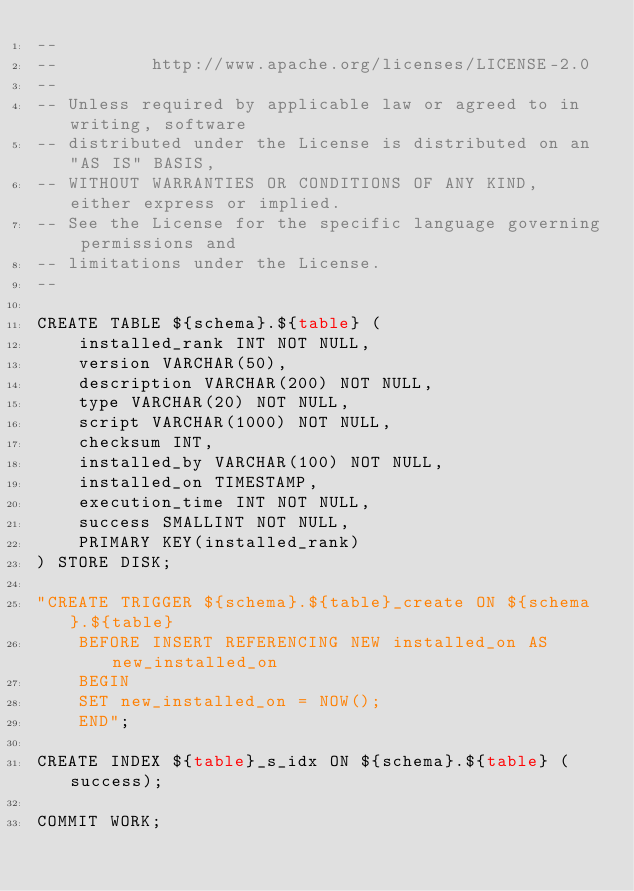<code> <loc_0><loc_0><loc_500><loc_500><_SQL_>--
--         http://www.apache.org/licenses/LICENSE-2.0
--
-- Unless required by applicable law or agreed to in writing, software
-- distributed under the License is distributed on an "AS IS" BASIS,
-- WITHOUT WARRANTIES OR CONDITIONS OF ANY KIND, either express or implied.
-- See the License for the specific language governing permissions and
-- limitations under the License.
--

CREATE TABLE ${schema}.${table} (
    installed_rank INT NOT NULL,
    version VARCHAR(50),
    description VARCHAR(200) NOT NULL,
    type VARCHAR(20) NOT NULL,
    script VARCHAR(1000) NOT NULL,
    checksum INT,
    installed_by VARCHAR(100) NOT NULL,
    installed_on TIMESTAMP,
    execution_time INT NOT NULL,
    success SMALLINT NOT NULL,
    PRIMARY KEY(installed_rank)
) STORE DISK;

"CREATE TRIGGER ${schema}.${table}_create ON ${schema}.${table}
    BEFORE INSERT REFERENCING NEW installed_on AS new_installed_on
    BEGIN
    SET new_installed_on = NOW();
    END";

CREATE INDEX ${table}_s_idx ON ${schema}.${table} (success);

COMMIT WORK;

</code> 